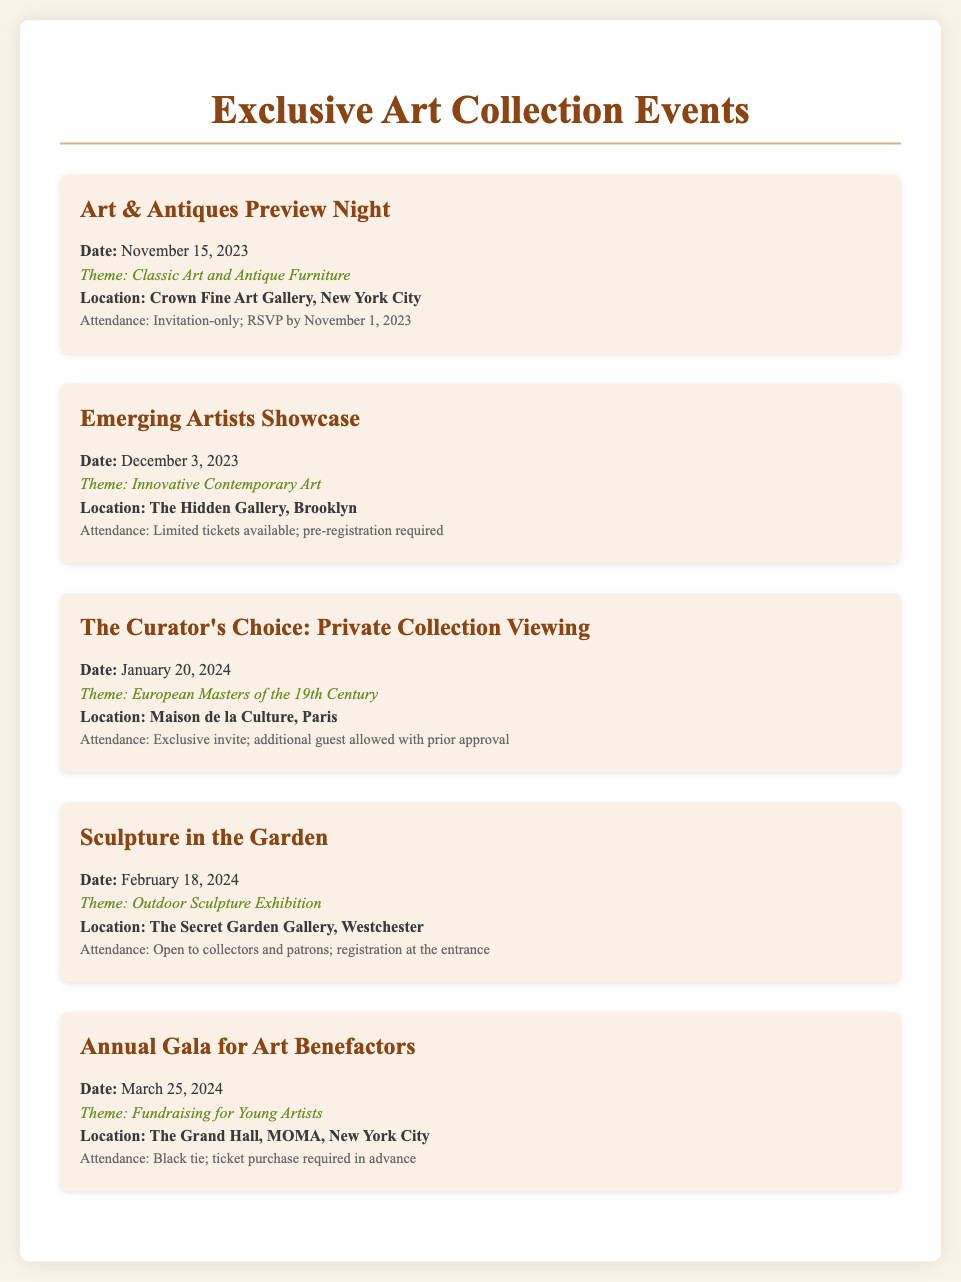What is the date of the Art & Antiques Preview Night? The document lists the date of the Art & Antiques Preview Night as November 15, 2023.
Answer: November 15, 2023 What is the theme of the Emerging Artists Showcase? According to the document, the theme of the Emerging Artists Showcase is Innovative Contemporary Art.
Answer: Innovative Contemporary Art Where is the sculpture exhibit taking place? The document states that the Sculpture in the Garden event will be held at The Secret Garden Gallery, Westchester.
Answer: The Secret Garden Gallery, Westchester How many events are scheduled for 2024? Reviewing the document shows that there are two events scheduled for 2024: The Curator's Choice and Sculpture in the Garden.
Answer: Two What is required for attendance at the Annual Gala for Art Benefactors? The document specifies that attendance at the Annual Gala requires a black tie dress code and ticket purchase in advance.
Answer: Black tie; ticket purchase required in advance 